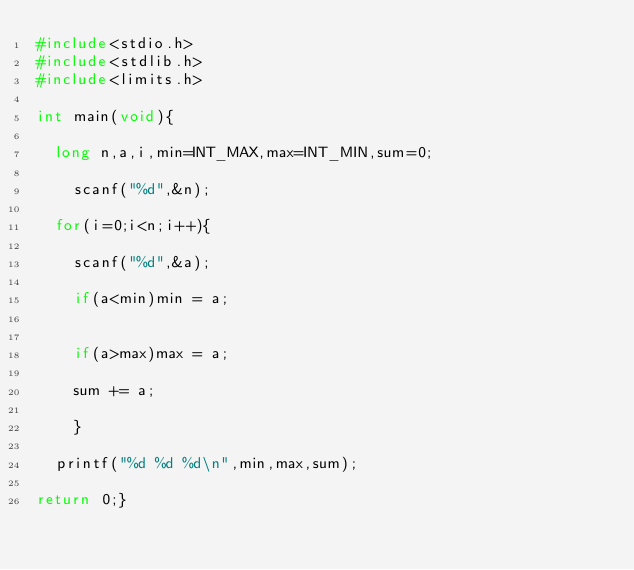Convert code to text. <code><loc_0><loc_0><loc_500><loc_500><_C_>#include<stdio.h>
#include<stdlib.h>
#include<limits.h>

int main(void){
	
	long n,a,i,min=INT_MAX,max=INT_MIN,sum=0;
	
		scanf("%d",&n);
	
	for(i=0;i<n;i++){
		
		scanf("%d",&a);
		
		if(a<min)min = a;
		
		
		if(a>max)max = a;
		
		sum += a;
		
		}
	
	printf("%d %d %d\n",min,max,sum);
	
return 0;}</code> 